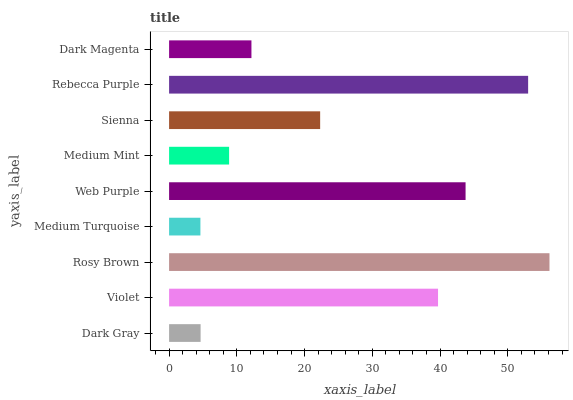Is Medium Turquoise the minimum?
Answer yes or no. Yes. Is Rosy Brown the maximum?
Answer yes or no. Yes. Is Violet the minimum?
Answer yes or no. No. Is Violet the maximum?
Answer yes or no. No. Is Violet greater than Dark Gray?
Answer yes or no. Yes. Is Dark Gray less than Violet?
Answer yes or no. Yes. Is Dark Gray greater than Violet?
Answer yes or no. No. Is Violet less than Dark Gray?
Answer yes or no. No. Is Sienna the high median?
Answer yes or no. Yes. Is Sienna the low median?
Answer yes or no. Yes. Is Rosy Brown the high median?
Answer yes or no. No. Is Violet the low median?
Answer yes or no. No. 